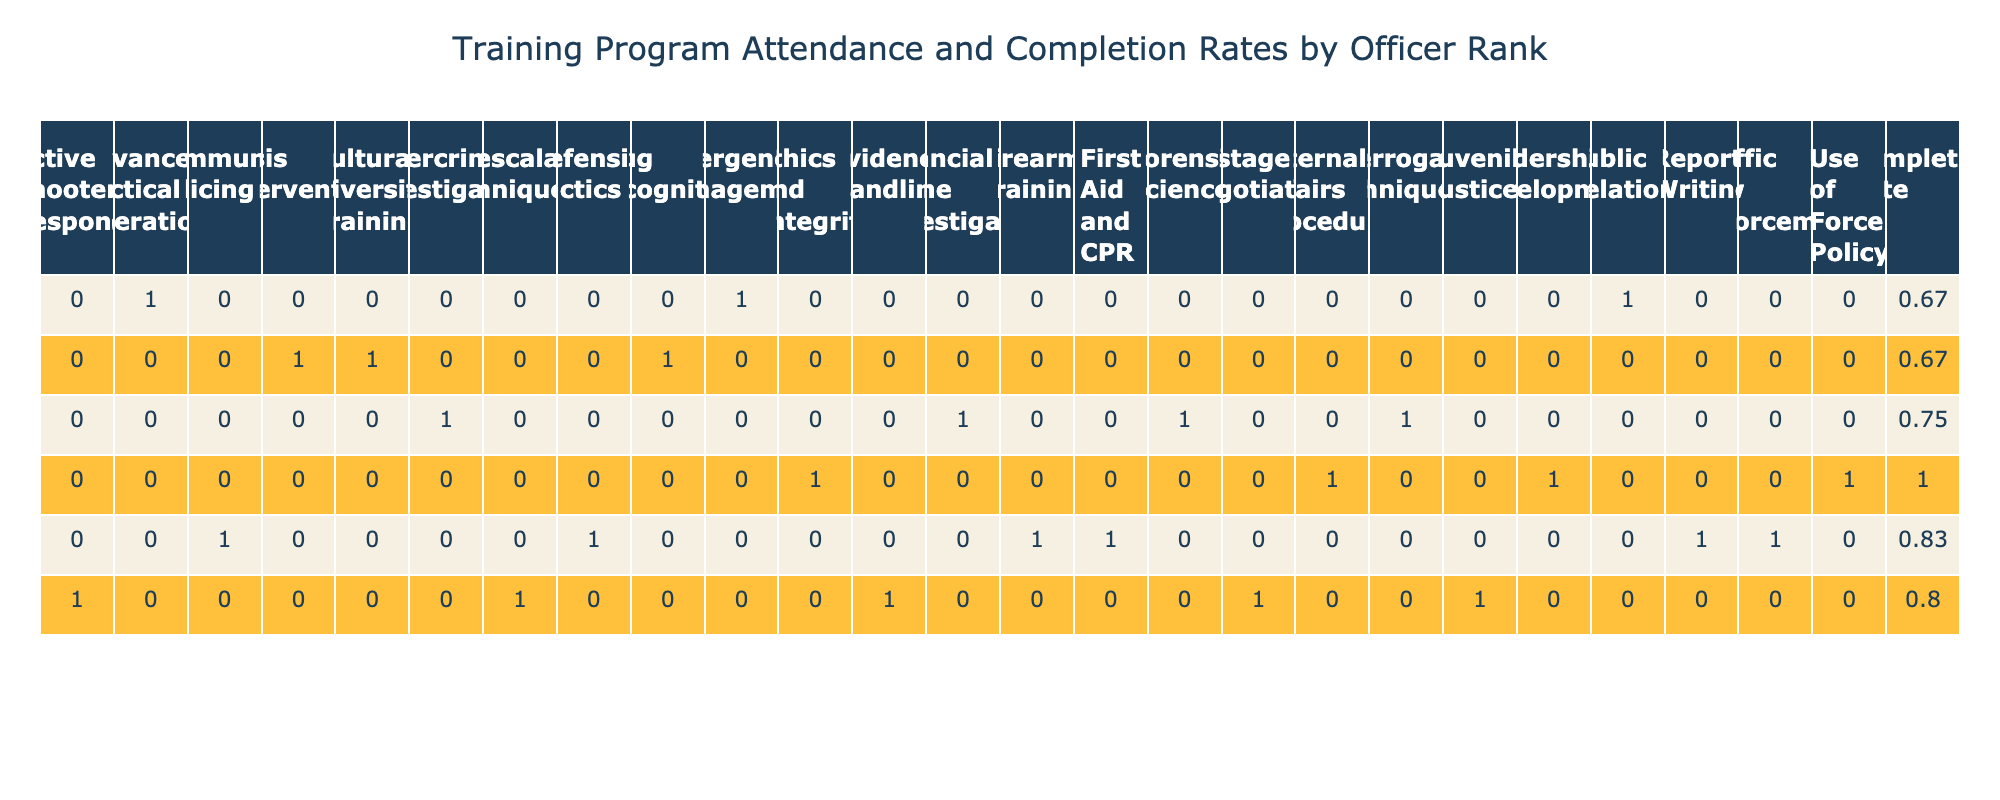What is the total number of Sergeant officers who attended training programs? To find the total number of Sergeant officers who attended training programs, I look at the "Sergent" row in the first column of the table. The count of officer IDs under the attendance for that rank, provides the number of courses taken. There are 5 training programs listed for Sergeants.
Answer: 5 What is the completion rate for Detectives? To calculate the completion rate for Detectives, I need to look at the "Completion" status in the Detective row. There are a total of 5 programs attended by Detectives, with 4 marked as "Yes" and 1 as "No". The completion rate is therefore 4 completed out of 5 courses attended, giving us a rate of 4/5 = 0.8 or 80%.
Answer: 0.8 Did any Captains have a completion rate of 100%? I review the completion status for Captains in the table. There are 4 training programs listed, but only 2 of them have a "Yes" completion status. Thus, none of the Captains achieved a completion rate of 100%.
Answer: No Which officer rank had the highest attendance in 'Crisis Intervention'? I check the attendance for the course 'Crisis Intervention'. The row for each officer rank is evaluated against this course name. Only Corporals are recorded for this training, showing that they had 1 attendee as indicated in the table.
Answer: Corporal What is the average completion rate for all officer ranks? To compute the average completion rate, I analyze the completion data across all ranks. I calculate the completion rate for each rank by counting the "Yes" responses divided by total courses attended for that rank. The individual completion rates are: Sergeant (4/5), Patrol Officer (5/6), Detective (4/5), Lieutenant (4/5), Captain (2/4), and Corporal (1/3). Summing these gives a total of 20 completions out of 28 total attendance, resulting in an average completion rate of 20/28 = 0.714 or 71.4%.
Answer: 0.714 